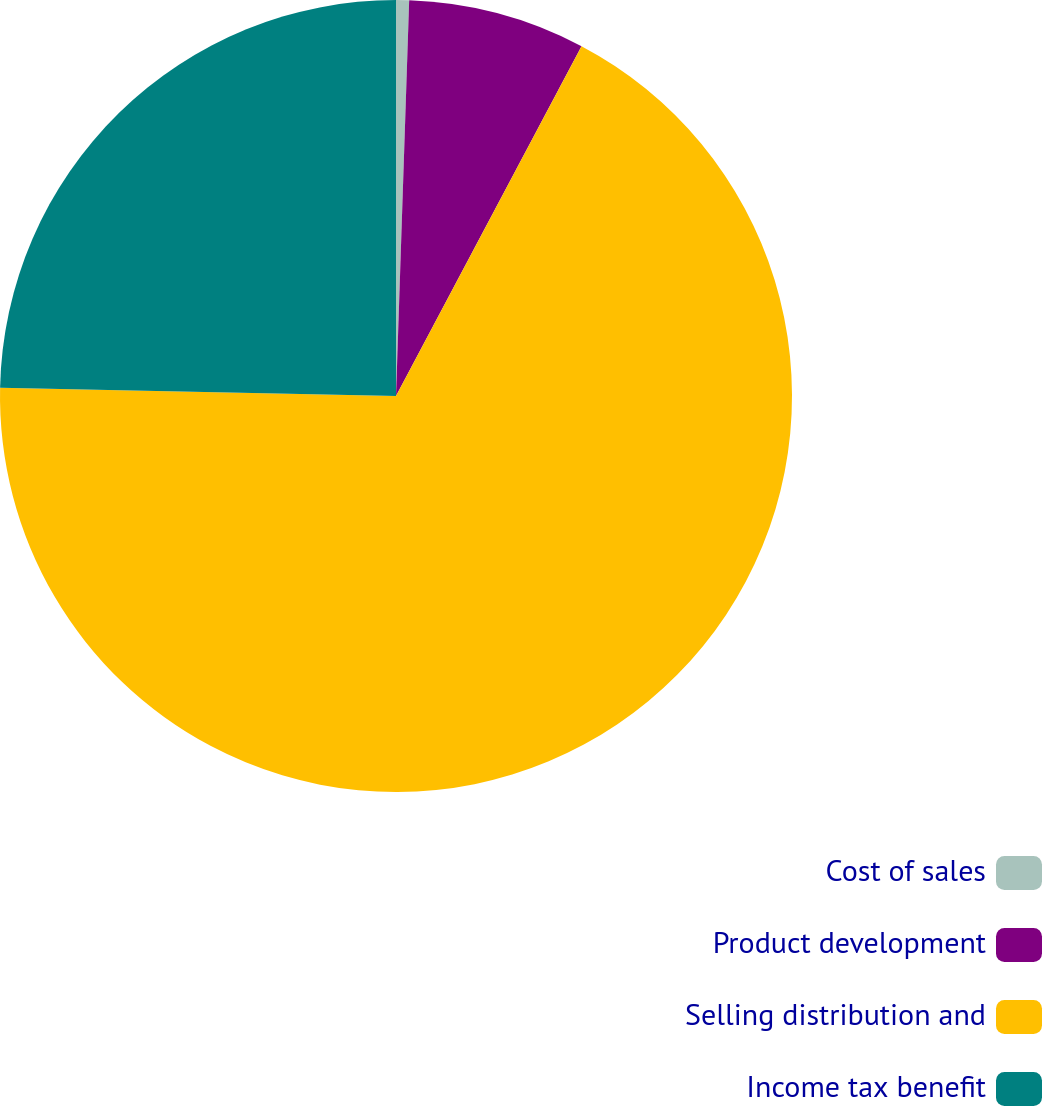Convert chart. <chart><loc_0><loc_0><loc_500><loc_500><pie_chart><fcel>Cost of sales<fcel>Product development<fcel>Selling distribution and<fcel>Income tax benefit<nl><fcel>0.53%<fcel>7.23%<fcel>67.57%<fcel>24.67%<nl></chart> 